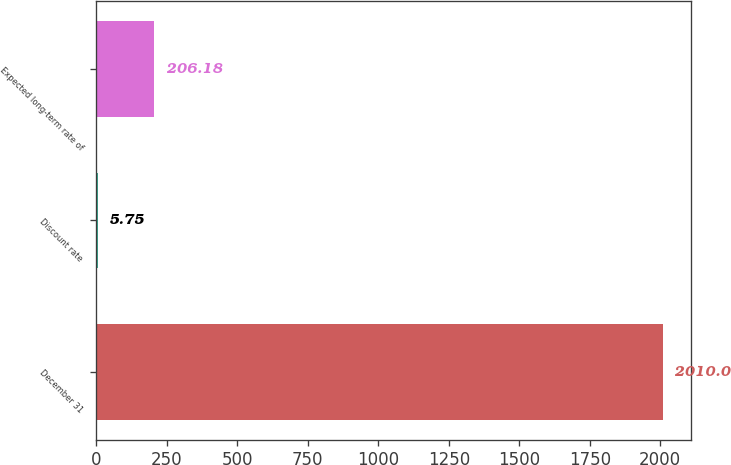<chart> <loc_0><loc_0><loc_500><loc_500><bar_chart><fcel>December 31<fcel>Discount rate<fcel>Expected long-term rate of<nl><fcel>2010<fcel>5.75<fcel>206.18<nl></chart> 